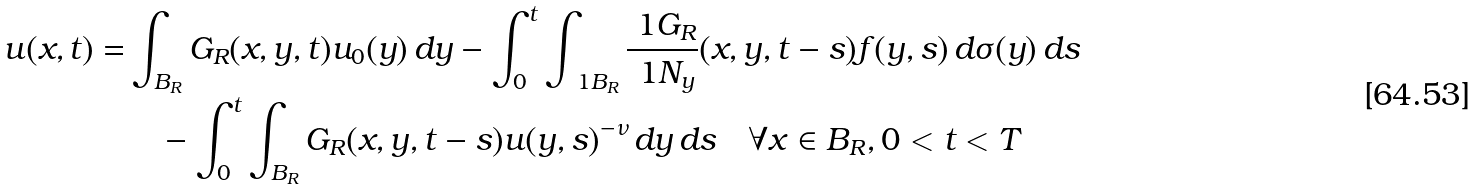<formula> <loc_0><loc_0><loc_500><loc_500>u ( x , t ) = & \int _ { B _ { R } } G _ { R } ( x , y , t ) u _ { 0 } ( y ) \, d y - \int _ { 0 } ^ { t } \int _ { \ 1 B _ { R } } \frac { \ 1 G _ { R } } { \ 1 N _ { y } } ( x , y , t - s ) f ( y , s ) \, d \sigma ( y ) \, d s \\ & \quad - \int _ { 0 } ^ { t } \int _ { B _ { R } } G _ { R } ( x , y , t - s ) u ( y , s ) ^ { - \nu } \, d y \, d s \quad \forall x \in B _ { R } , 0 < t < T</formula> 